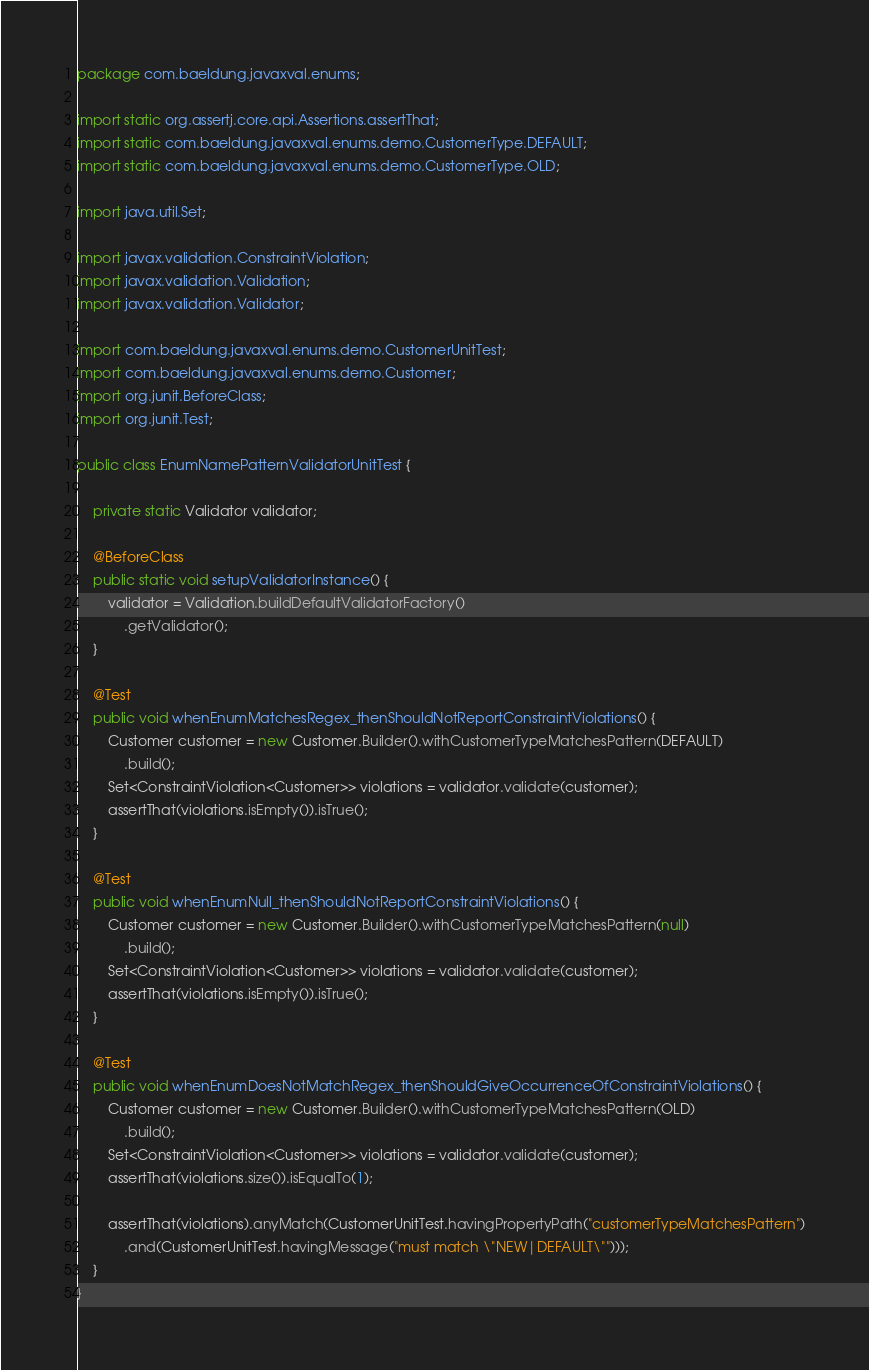<code> <loc_0><loc_0><loc_500><loc_500><_Java_>package com.baeldung.javaxval.enums;

import static org.assertj.core.api.Assertions.assertThat;
import static com.baeldung.javaxval.enums.demo.CustomerType.DEFAULT;
import static com.baeldung.javaxval.enums.demo.CustomerType.OLD;

import java.util.Set;

import javax.validation.ConstraintViolation;
import javax.validation.Validation;
import javax.validation.Validator;

import com.baeldung.javaxval.enums.demo.CustomerUnitTest;
import com.baeldung.javaxval.enums.demo.Customer;
import org.junit.BeforeClass;
import org.junit.Test;

public class EnumNamePatternValidatorUnitTest {

    private static Validator validator;

    @BeforeClass
    public static void setupValidatorInstance() {
        validator = Validation.buildDefaultValidatorFactory()
            .getValidator();
    }

    @Test
    public void whenEnumMatchesRegex_thenShouldNotReportConstraintViolations() {
        Customer customer = new Customer.Builder().withCustomerTypeMatchesPattern(DEFAULT)
            .build();
        Set<ConstraintViolation<Customer>> violations = validator.validate(customer);
        assertThat(violations.isEmpty()).isTrue();
    }

    @Test
    public void whenEnumNull_thenShouldNotReportConstraintViolations() {
        Customer customer = new Customer.Builder().withCustomerTypeMatchesPattern(null)
            .build();
        Set<ConstraintViolation<Customer>> violations = validator.validate(customer);
        assertThat(violations.isEmpty()).isTrue();
    }

    @Test
    public void whenEnumDoesNotMatchRegex_thenShouldGiveOccurrenceOfConstraintViolations() {
        Customer customer = new Customer.Builder().withCustomerTypeMatchesPattern(OLD)
            .build();
        Set<ConstraintViolation<Customer>> violations = validator.validate(customer);
        assertThat(violations.size()).isEqualTo(1);

        assertThat(violations).anyMatch(CustomerUnitTest.havingPropertyPath("customerTypeMatchesPattern")
            .and(CustomerUnitTest.havingMessage("must match \"NEW|DEFAULT\"")));
    }
}</code> 